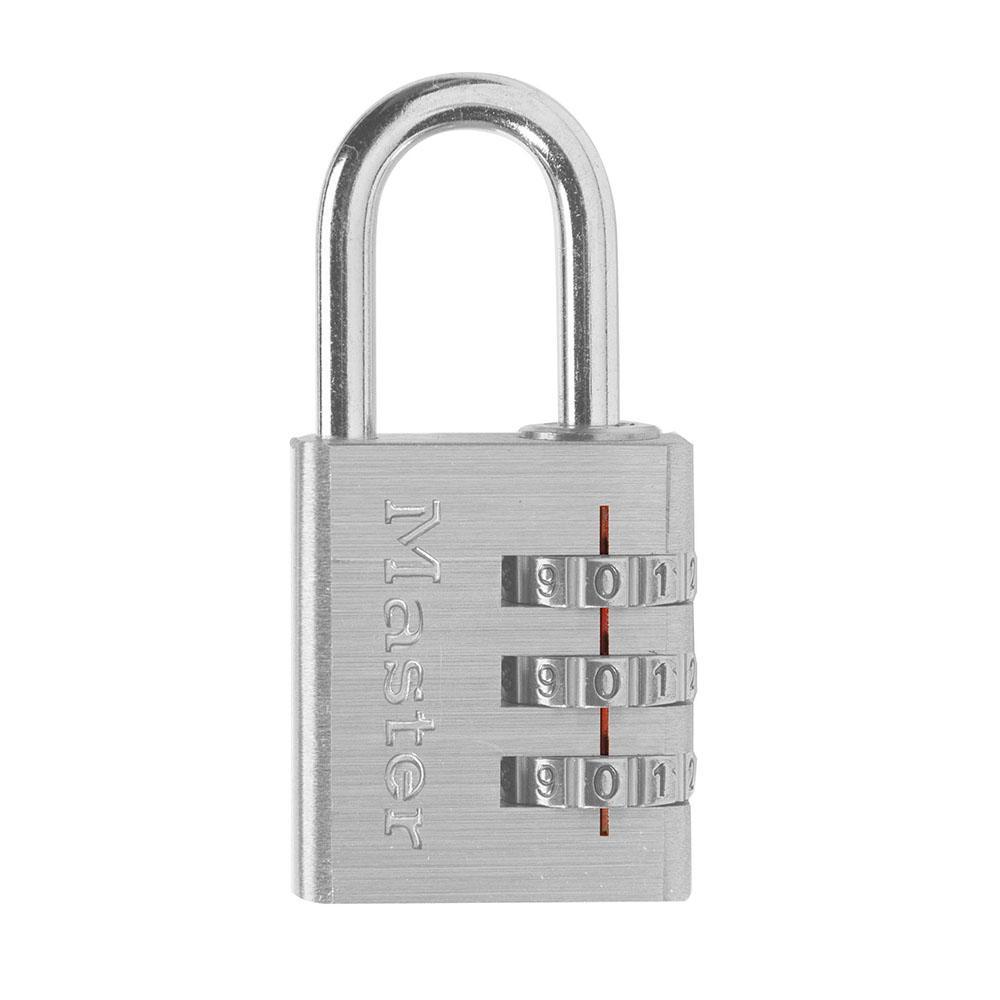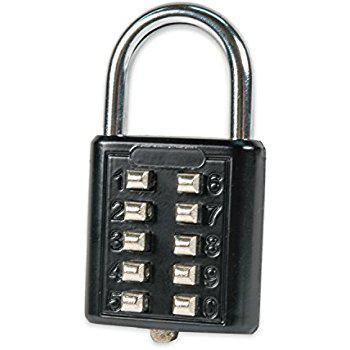The first image is the image on the left, the second image is the image on the right. For the images displayed, is the sentence "Two padlocks each have a different belt combination system and are different colors, but are both locked and have silver locking loops." factually correct? Answer yes or no. Yes. 